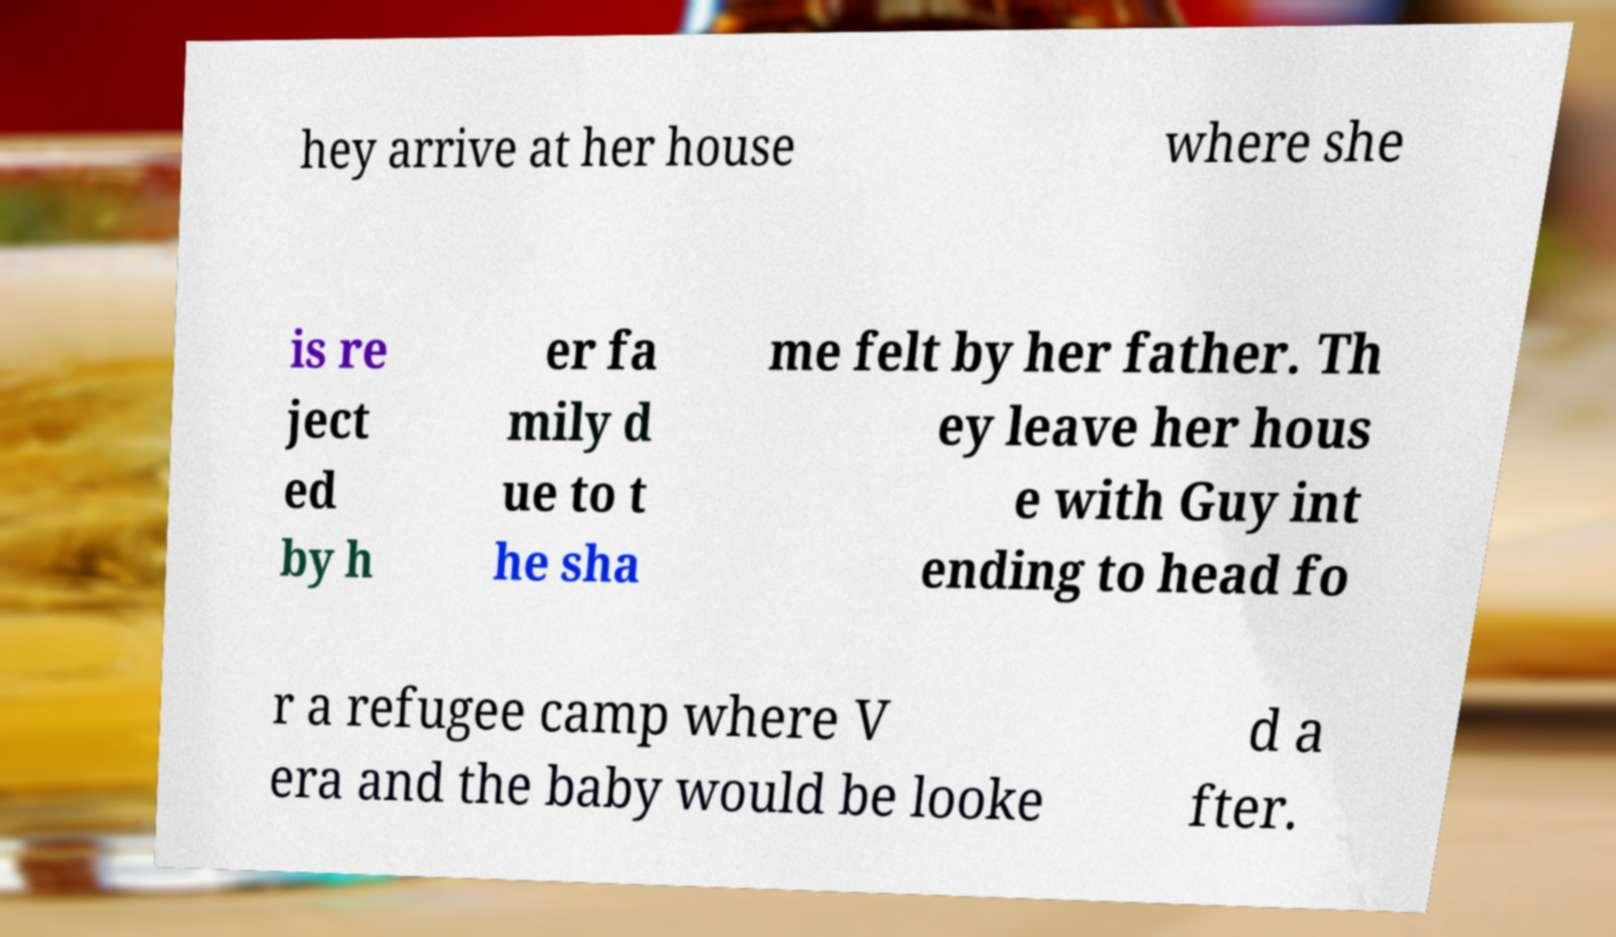Please identify and transcribe the text found in this image. hey arrive at her house where she is re ject ed by h er fa mily d ue to t he sha me felt by her father. Th ey leave her hous e with Guy int ending to head fo r a refugee camp where V era and the baby would be looke d a fter. 